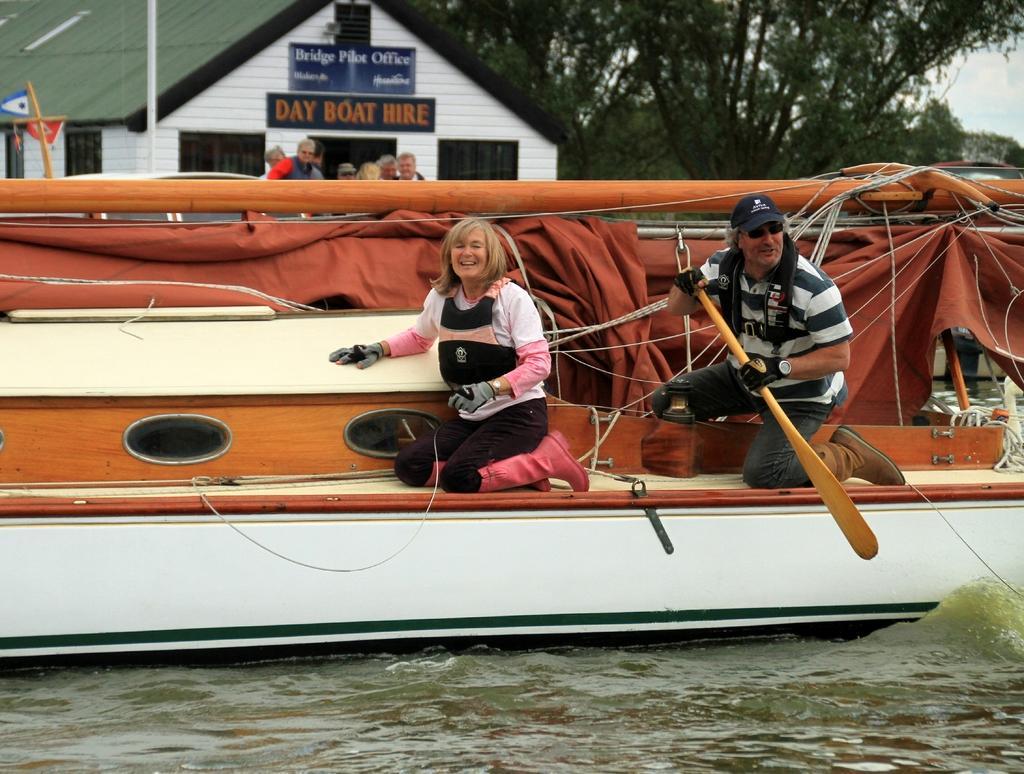Could you give a brief overview of what you see in this image? In this image we can see there are two persons sitting on the boat and the other person holding a paddle. And we can see the water, trees, sticks and persons standing. There are boards with text attached to the house and the sky in the background. 